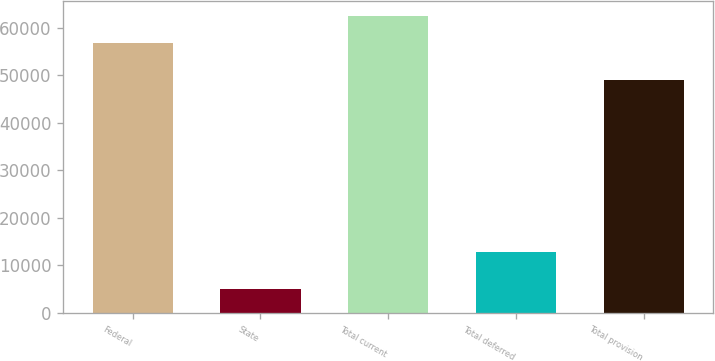Convert chart. <chart><loc_0><loc_0><loc_500><loc_500><bar_chart><fcel>Federal<fcel>State<fcel>Total current<fcel>Total deferred<fcel>Total provision<nl><fcel>56917<fcel>4961<fcel>62608.7<fcel>12735<fcel>49143<nl></chart> 